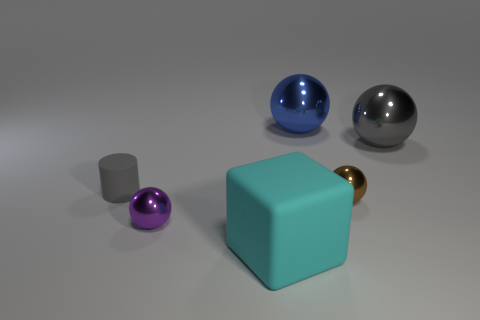There is a sphere that is on the left side of the big cyan cube; what size is it?
Your answer should be very brief. Small. What number of tiny spheres are to the right of the big blue sphere that is to the left of the gray thing that is behind the tiny gray object?
Give a very brief answer. 1. There is a large blue ball; are there any big blue objects left of it?
Ensure brevity in your answer.  No. What number of other things are the same size as the blue sphere?
Your response must be concise. 2. What is the big thing that is both left of the tiny brown sphere and on the right side of the large cyan object made of?
Your response must be concise. Metal. Do the tiny object that is to the right of the blue ball and the gray object that is left of the cyan rubber thing have the same shape?
Provide a succinct answer. No. Are there any other things that have the same material as the blue thing?
Provide a succinct answer. Yes. The object that is left of the sphere that is on the left side of the large object in front of the tiny gray thing is what shape?
Provide a succinct answer. Cylinder. What number of other things are there of the same shape as the purple metallic thing?
Keep it short and to the point. 3. The matte cube that is the same size as the gray ball is what color?
Keep it short and to the point. Cyan. 